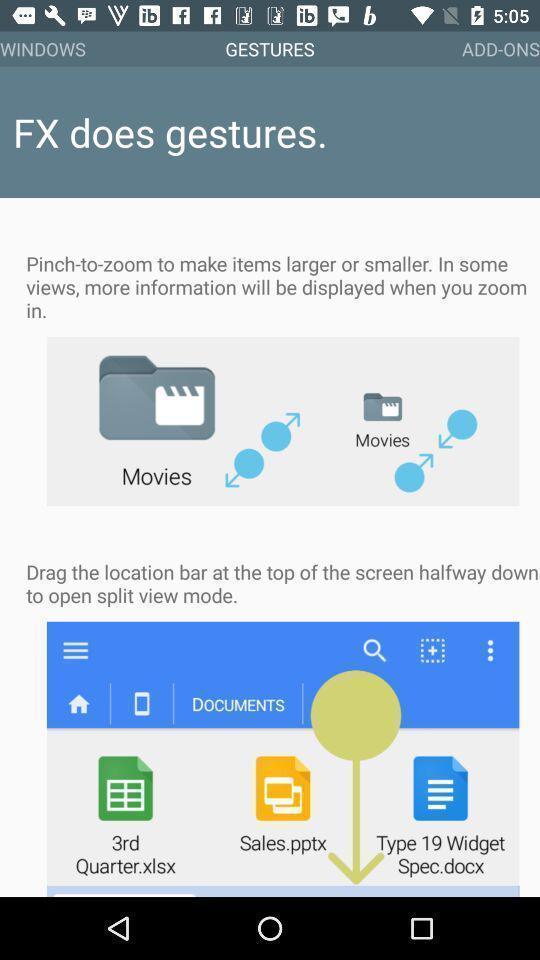Describe the visual elements of this screenshot. Welcome page. 